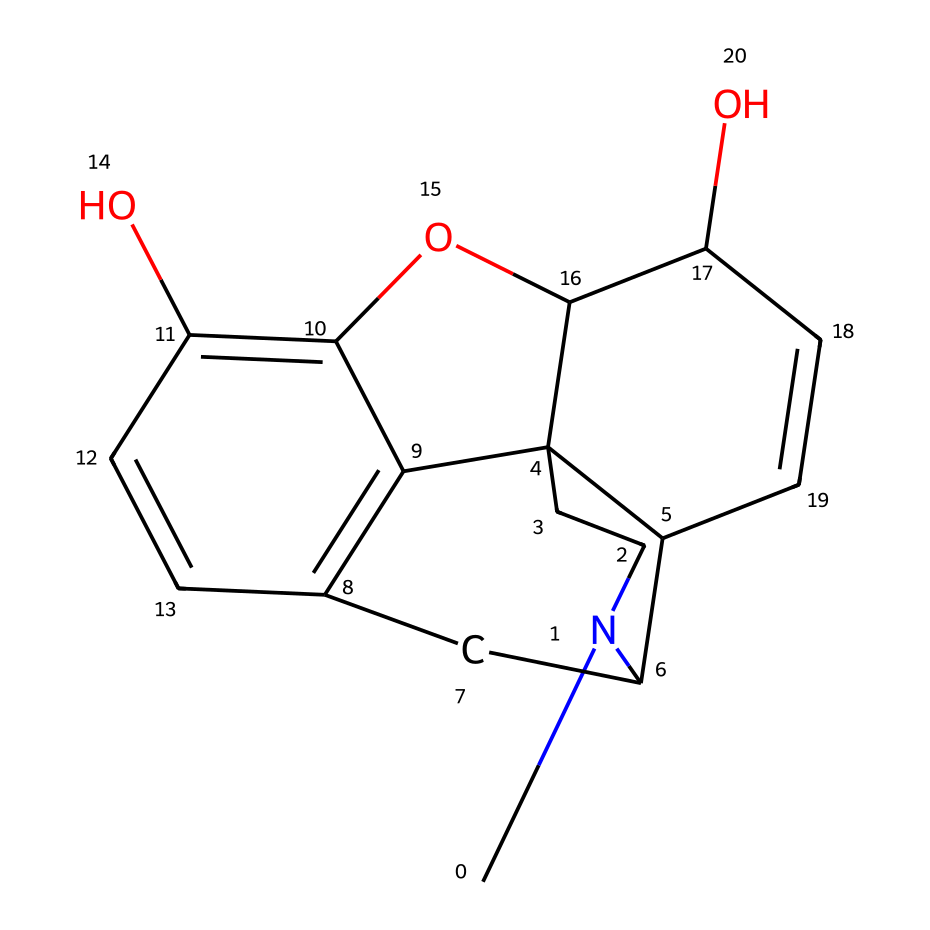What is the molecular formula for morphine based on the structure? To find the molecular formula, we count the number of each type of atom present in the structure. In the provided SMILES representation, there are 17 carbon (C) atoms, 19 hydrogen (H) atoms, 3 nitrogen (N) atoms, and 3 oxygen (O) atoms. Putting this together, the molecular formula is C17H19N3O3.
Answer: C17H19N3O3 How many rings are present in the structure of morphine? By analyzing the connections within the structure represented by the SMILES, we can identify distinct cyclic arrangements. In morphine, there are five rings formed by the carbon atoms.
Answer: five What part of the morphine structure contributes to its analgesic properties? The presence of nitrogen atoms in the structure of morphine is key, as many alkaloids, including morphine, act on opioid receptors in the brain to provide pain relief. The nitrogen in the structure contributes to this interaction with the receptors.
Answer: nitrogen Which functional groups are present in the morphine structure? Looking closely at the structure, we can identify hydroxyl groups (-OH) and an ether group (-O-). Specifically, morphine contains two hydroxyl groups and one ether group, which are important for its biological activity.
Answer: hydroxyl and ether groups What type of chemical is morphine classified as? Morphine is classified as an alkaloid due to the presence of nitrogen atoms and its natural occurrence in plants that produce it, particularly opium poppies. Alkaloids are known for their pharmacological effects.
Answer: alkaloid How does the presence of multiple hydroxyl groups affect morphine’s solubility? The multiple hydroxyl groups in the morphine structure enhance its ability to form hydrogen bonds with water molecules, increasing its solubility in polar solvents. This is typical for compounds with hydroxyl functional groups.
Answer: increases solubility 